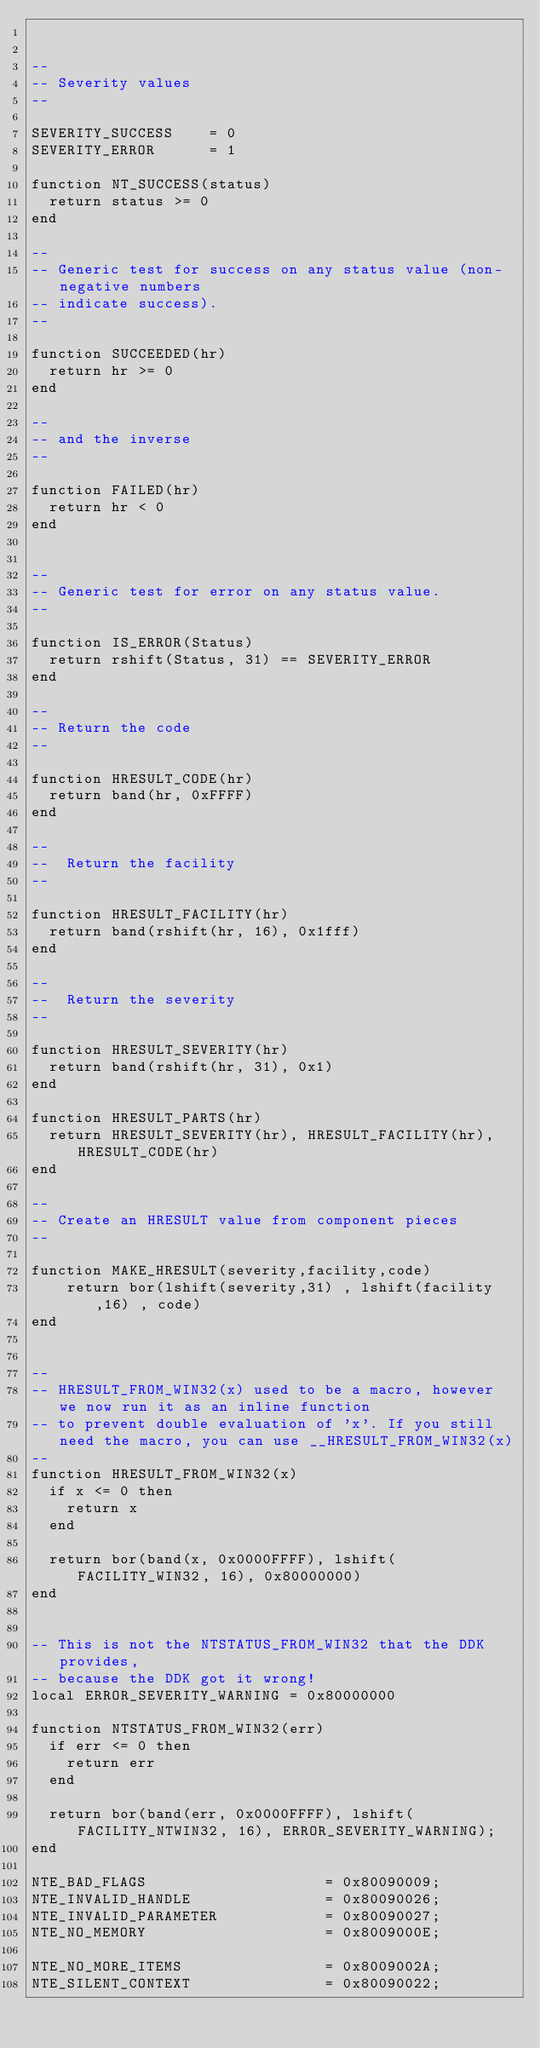Convert code to text. <code><loc_0><loc_0><loc_500><loc_500><_Lua_>

--
-- Severity values
--

SEVERITY_SUCCESS    = 0
SEVERITY_ERROR      = 1

function NT_SUCCESS(status) 
	return status >= 0
end

--
-- Generic test for success on any status value (non-negative numbers
-- indicate success).
--

function SUCCEEDED(hr)
	return hr >= 0
end

--
-- and the inverse
--

function FAILED(hr)
	return hr < 0
end


--
-- Generic test for error on any status value.
--

function IS_ERROR(Status)
	return rshift(Status, 31) == SEVERITY_ERROR
end

--
-- Return the code
--

function HRESULT_CODE(hr)
	return band(hr, 0xFFFF)
end

--
--  Return the facility
--

function HRESULT_FACILITY(hr)
	return band(rshift(hr, 16), 0x1fff)
end

--
--  Return the severity
--

function HRESULT_SEVERITY(hr)
	return band(rshift(hr, 31), 0x1)
end

function HRESULT_PARTS(hr)
	return HRESULT_SEVERITY(hr), HRESULT_FACILITY(hr), HRESULT_CODE(hr)
end

--
-- Create an HRESULT value from component pieces
--

function MAKE_HRESULT(severity,facility,code)
    return bor(lshift(severity,31) , lshift(facility,16) , code)
end


--
-- HRESULT_FROM_WIN32(x) used to be a macro, however we now run it as an inline function
-- to prevent double evaluation of 'x'. If you still need the macro, you can use __HRESULT_FROM_WIN32(x)
--
function HRESULT_FROM_WIN32(x)
	if x <= 0 then
		return x
	end

	return bor(band(x, 0x0000FFFF), lshift(FACILITY_WIN32, 16), 0x80000000)
end


-- This is not the NTSTATUS_FROM_WIN32 that the DDK provides, 
-- because the DDK got it wrong!
local ERROR_SEVERITY_WARNING = 0x80000000

function NTSTATUS_FROM_WIN32(err) 
	if err <= 0 then
		return err
	end
	
	return bor(band(err, 0x0000FFFF), lshift(FACILITY_NTWIN32, 16), ERROR_SEVERITY_WARNING);
end

NTE_BAD_FLAGS                    = 0x80090009;
NTE_INVALID_HANDLE               = 0x80090026;
NTE_INVALID_PARAMETER            = 0x80090027;
NTE_NO_MEMORY                    = 0x8009000E;

NTE_NO_MORE_ITEMS                = 0x8009002A;
NTE_SILENT_CONTEXT               = 0x80090022;
</code> 